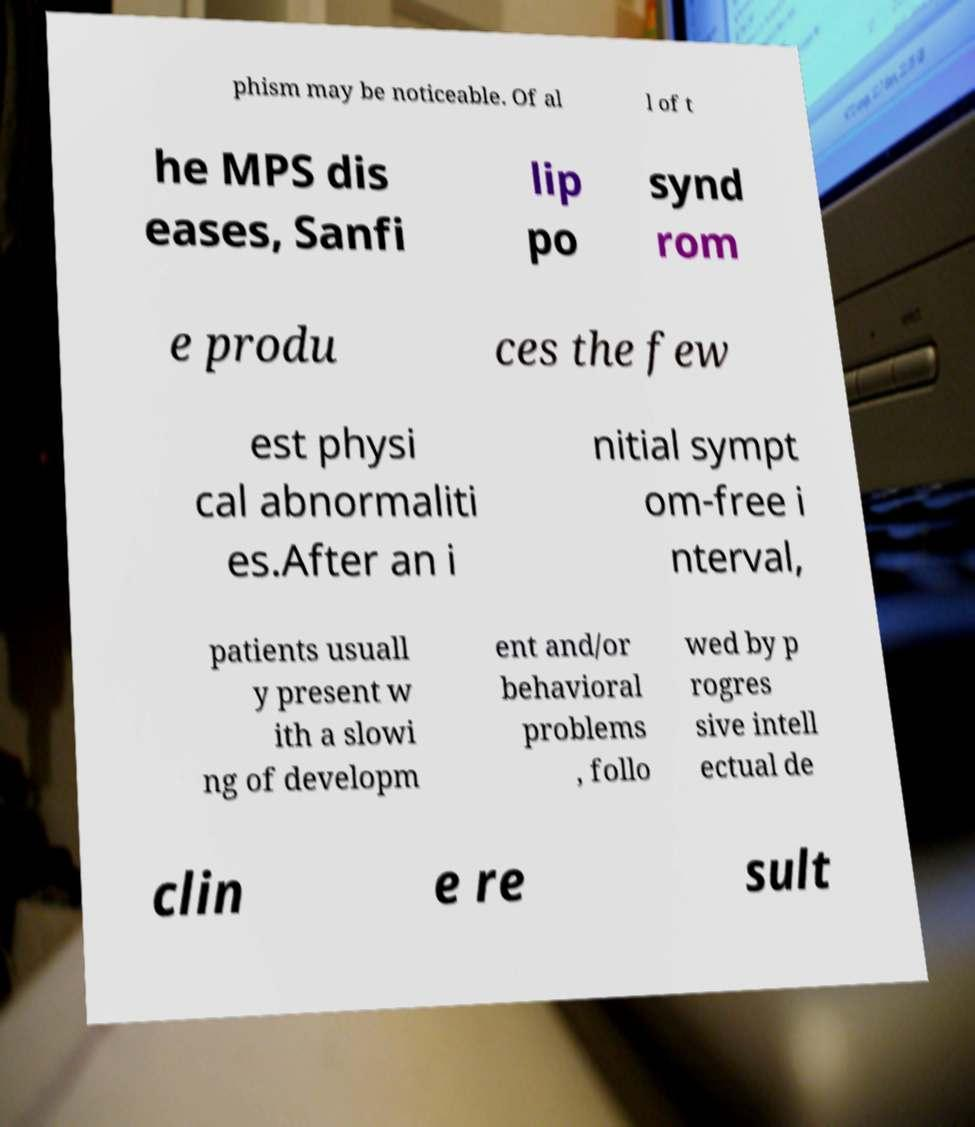There's text embedded in this image that I need extracted. Can you transcribe it verbatim? phism may be noticeable. Of al l of t he MPS dis eases, Sanfi lip po synd rom e produ ces the few est physi cal abnormaliti es.After an i nitial sympt om-free i nterval, patients usuall y present w ith a slowi ng of developm ent and/or behavioral problems , follo wed by p rogres sive intell ectual de clin e re sult 